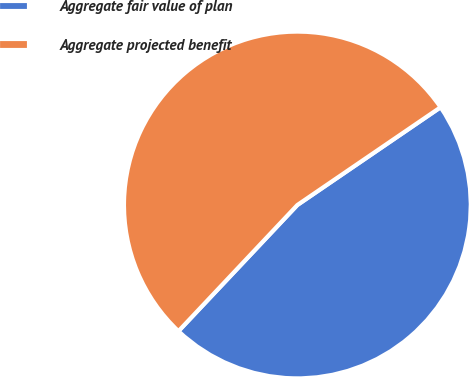<chart> <loc_0><loc_0><loc_500><loc_500><pie_chart><fcel>Aggregate fair value of plan<fcel>Aggregate projected benefit<nl><fcel>46.56%<fcel>53.44%<nl></chart> 